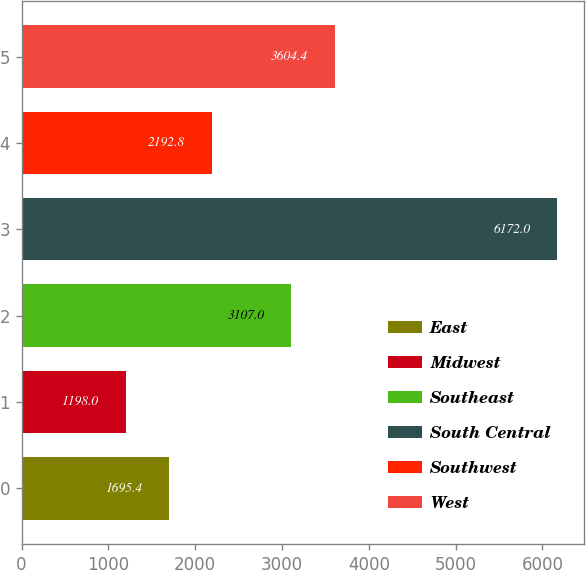<chart> <loc_0><loc_0><loc_500><loc_500><bar_chart><fcel>East<fcel>Midwest<fcel>Southeast<fcel>South Central<fcel>Southwest<fcel>West<nl><fcel>1695.4<fcel>1198<fcel>3107<fcel>6172<fcel>2192.8<fcel>3604.4<nl></chart> 